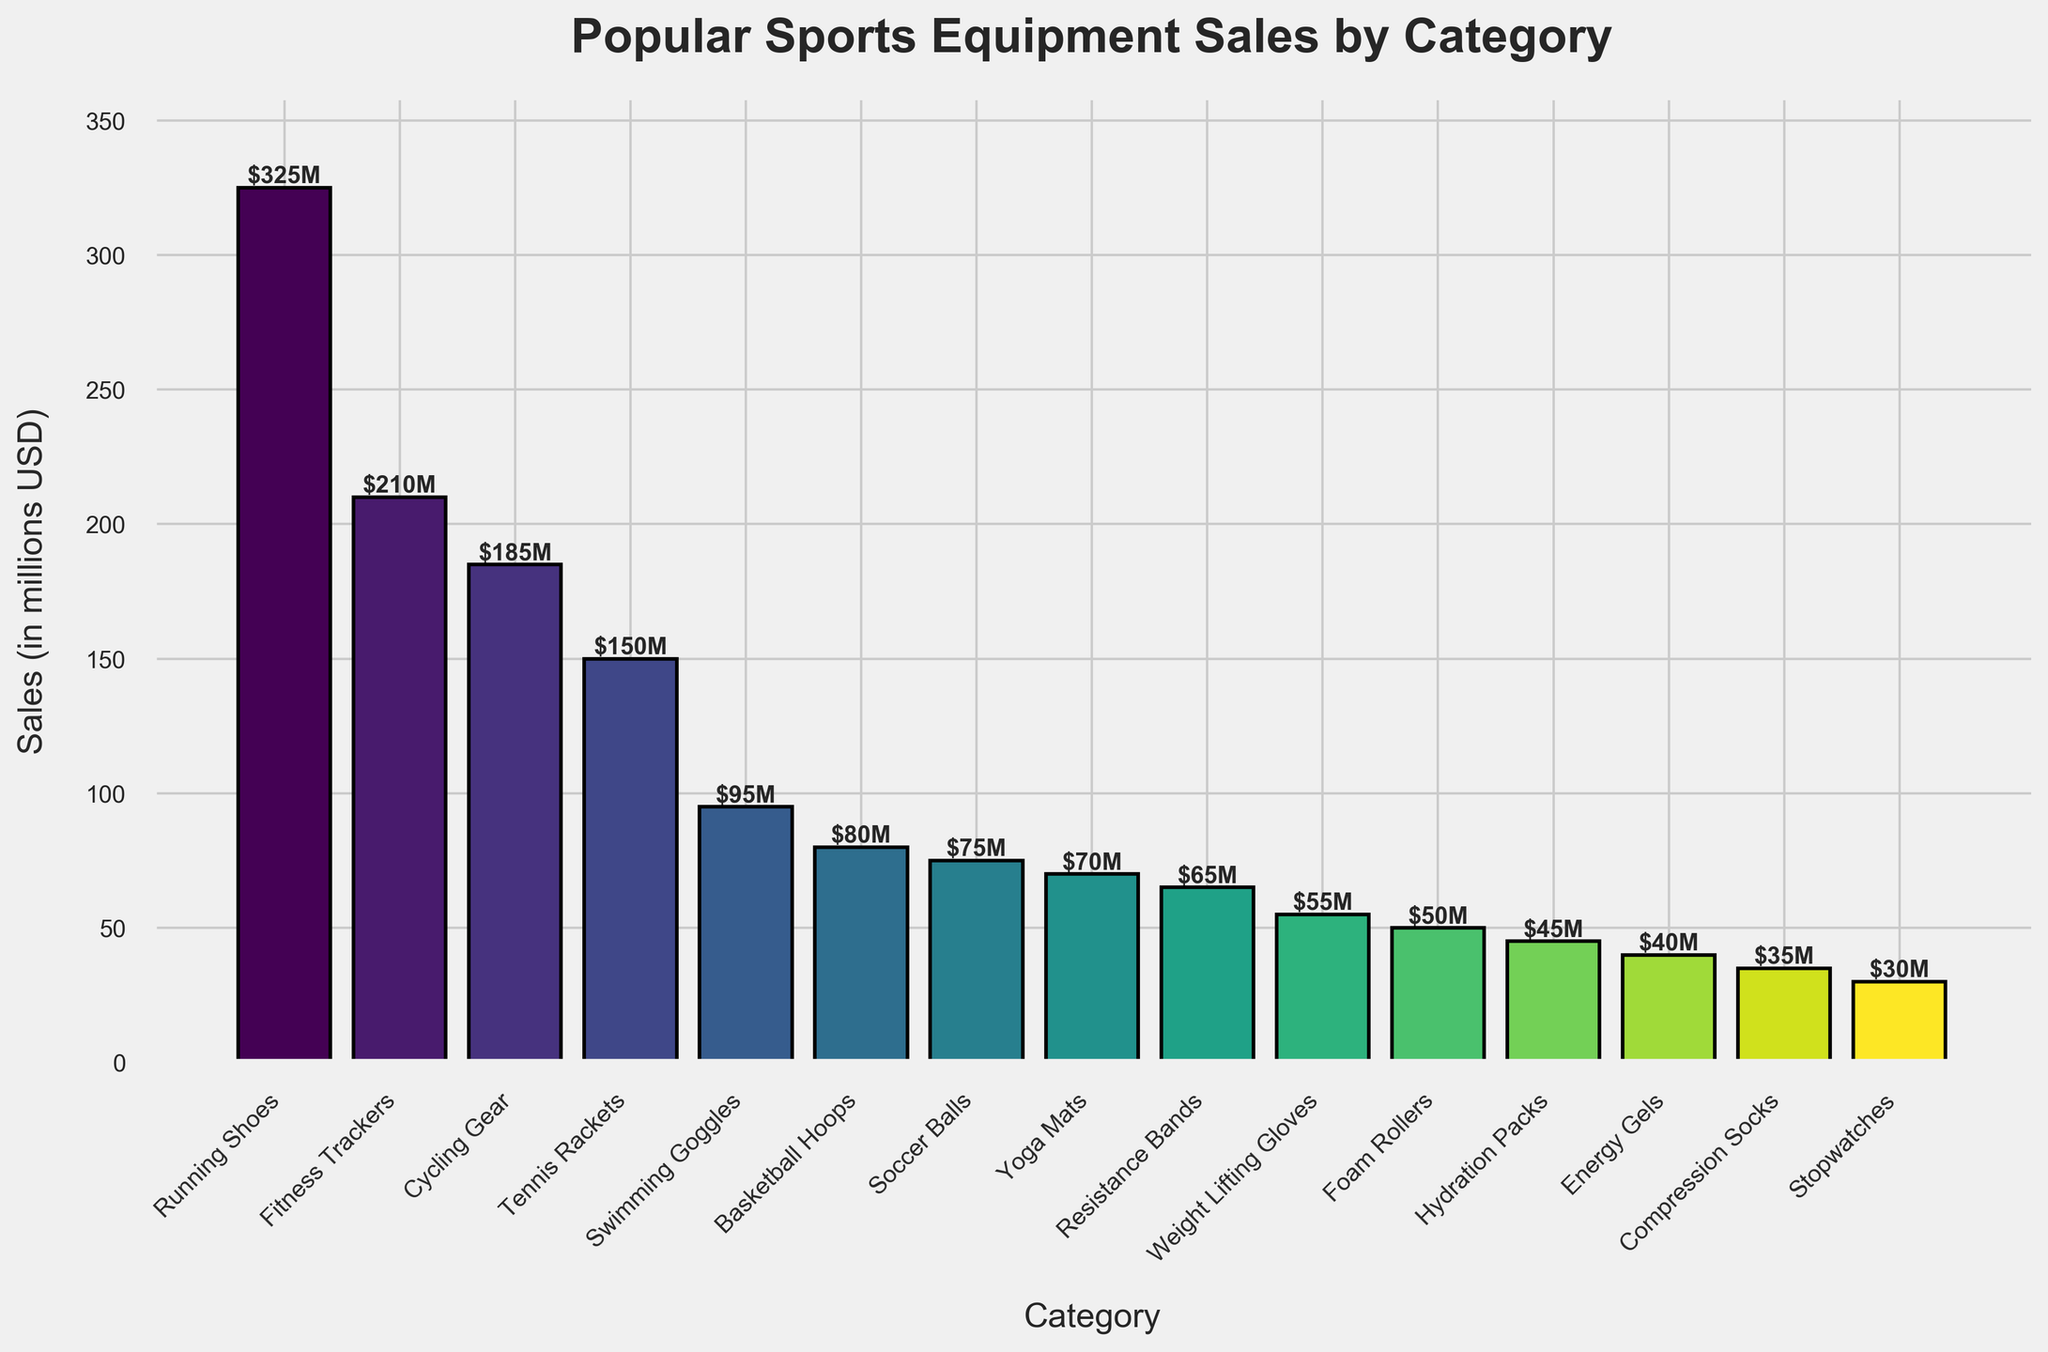What are the top three categories in terms of sales? The top three categories can be identified by looking at the height of the bars. The tallest bars represent the highest sales values. By visually inspecting the chart, the top three categories are Running Shoes, Fitness Trackers, and Cycling Gear.
Answer: Running Shoes, Fitness Trackers, Cycling Gear Which category has the lowest sales? The category with the lowest sales is represented by the shortest bar in the chart. Upon inspection, the shortest bar corresponds to Stopwatches.
Answer: Stopwatches What is the combined sale of Tennis Rackets, Swimming Goggles, and Soccer Balls? To find the combined sales, sum the sales values of Tennis Rackets (150M), Swimming Goggles (95M), and Soccer Balls (75M). The combined sales are 150 + 95 + 75 = 320M.
Answer: 320M Are the sales of Energy Gels higher or lower than the sales of Foam Rollers? By comparing the heights of the bars for Energy Gels and Foam Rollers, it can be seen that the bar for Foam Rollers is taller. This means the sales of Energy Gels (40M) are lower than those of Foam Rollers (50M).
Answer: Lower How much greater are the sales of Running Shoes compared to Weight Lifting Gloves? The sales of Running Shoes are 325M, and the sales of Weight Lifting Gloves are 55M. The difference between them is 325 - 55 = 270M.
Answer: 270M What is the average sales amount for all categories shown in the chart? To find the average sales, sum the sales for all categories and divide by the number of categories. Total sales = 325 + 210 + 185 + 150 + 95 + 80 + 75 + 70 + 65 + 55 + 50 + 45 + 40 + 35 + 30 = 1510M. There are 15 categories, so the average sales figure is 1510 / 15 ≈ 100.67M.
Answer: 100.67M Which visual attribute helps in identifying the highest sales category? The height of the bar in the bar chart visually indicates the sales amount, with taller bars representing higher sales.
Answer: Height of the bar What is the median sales value of the categories? To find the median sales value, arrange the sales figures in ascending order and find the middle value. Sorted values: 30, 35, 40, 45, 50, 55, 65, 70, 75, 80, 95, 150, 185, 210, 325. There are 15 categories, so the median is the 8th value, which is 70M.
Answer: 70M Which category has sales closest to $100M? By inspecting the bar heights and corresponding sales figures, the sales value closest to $100M is for Swimming Goggles, which is 95M.
Answer: Swimming Goggles Are the sales of Fitness Trackers and Cycling Gear together greater than the sales of Running Shoes? The combined sales of Fitness Trackers and Cycling Gear are 210M + 185M = 395M, while the sales of Running Shoes are 325M. Since 395M > 325M, their combined sales are greater.
Answer: Yes 